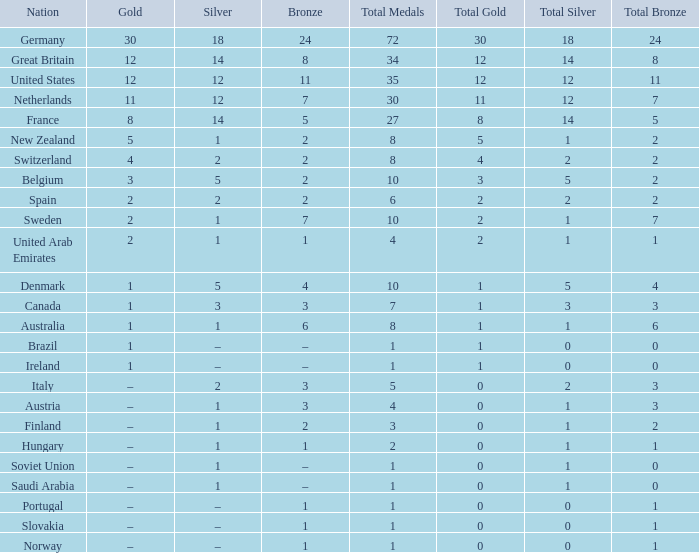What is Gold, when Silver is 5, and when Nation is Belgium? 3.0. 